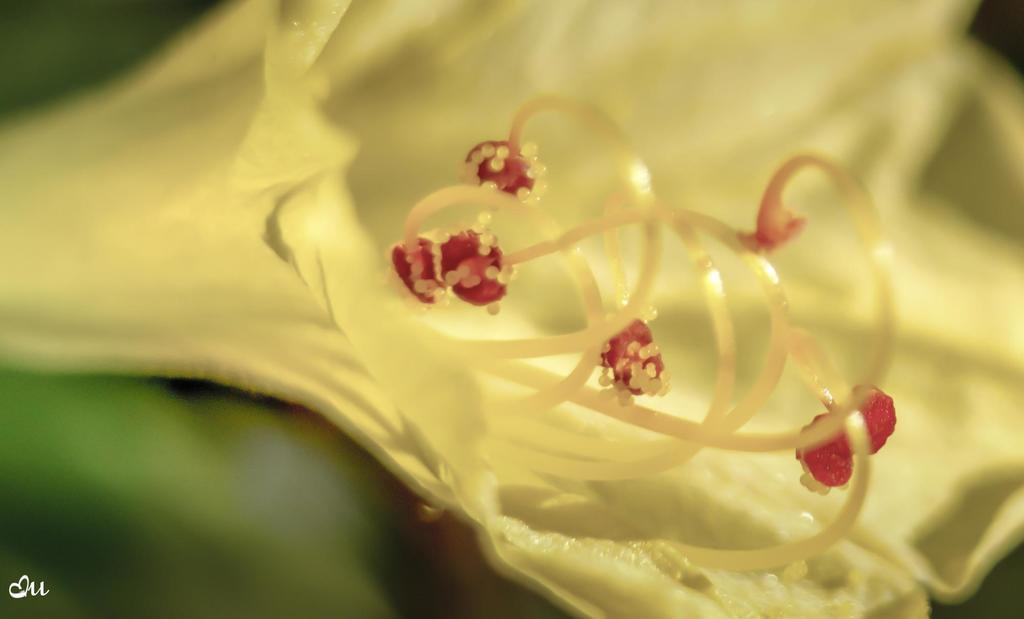What is the main subject of the image? There is a flower in the image. Can you describe the background of the image? The background of the image is blurred. Is there any text present in the image? Yes, there is text in the bottom left corner of the image. What type of toad can be seen sitting on the flower in the image? There is no toad present in the image; it only features a flower and a blurred background. Can you tell me how many animals are visible in the image? There are no animals visible in the image; it only features a flower and a blurred background. 